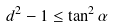Convert formula to latex. <formula><loc_0><loc_0><loc_500><loc_500>d ^ { 2 } - 1 \leq \tan ^ { 2 } \alpha</formula> 